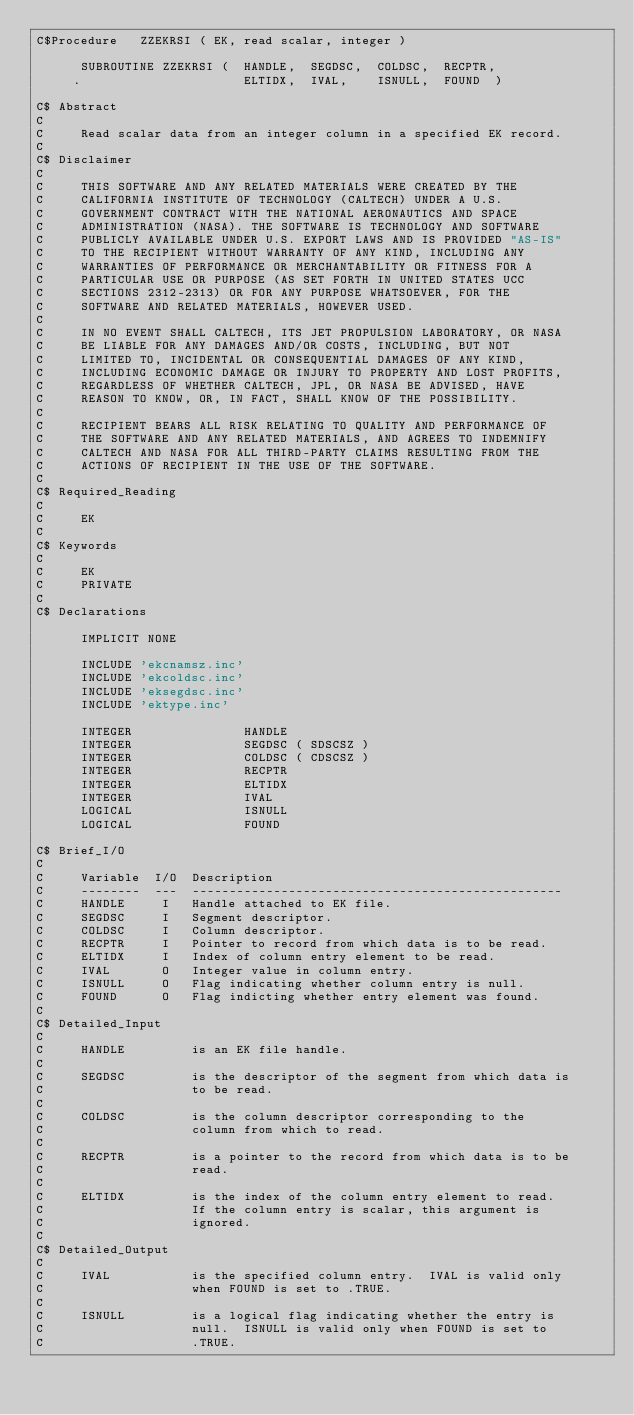<code> <loc_0><loc_0><loc_500><loc_500><_FORTRAN_>C$Procedure   ZZEKRSI ( EK, read scalar, integer )
 
      SUBROUTINE ZZEKRSI (  HANDLE,  SEGDSC,  COLDSC,  RECPTR,
     .                      ELTIDX,  IVAL,    ISNULL,  FOUND  )
 
C$ Abstract
C
C     Read scalar data from an integer column in a specified EK record.
C
C$ Disclaimer
C
C     THIS SOFTWARE AND ANY RELATED MATERIALS WERE CREATED BY THE
C     CALIFORNIA INSTITUTE OF TECHNOLOGY (CALTECH) UNDER A U.S.
C     GOVERNMENT CONTRACT WITH THE NATIONAL AERONAUTICS AND SPACE
C     ADMINISTRATION (NASA). THE SOFTWARE IS TECHNOLOGY AND SOFTWARE
C     PUBLICLY AVAILABLE UNDER U.S. EXPORT LAWS AND IS PROVIDED "AS-IS"
C     TO THE RECIPIENT WITHOUT WARRANTY OF ANY KIND, INCLUDING ANY
C     WARRANTIES OF PERFORMANCE OR MERCHANTABILITY OR FITNESS FOR A
C     PARTICULAR USE OR PURPOSE (AS SET FORTH IN UNITED STATES UCC
C     SECTIONS 2312-2313) OR FOR ANY PURPOSE WHATSOEVER, FOR THE
C     SOFTWARE AND RELATED MATERIALS, HOWEVER USED.
C
C     IN NO EVENT SHALL CALTECH, ITS JET PROPULSION LABORATORY, OR NASA
C     BE LIABLE FOR ANY DAMAGES AND/OR COSTS, INCLUDING, BUT NOT
C     LIMITED TO, INCIDENTAL OR CONSEQUENTIAL DAMAGES OF ANY KIND,
C     INCLUDING ECONOMIC DAMAGE OR INJURY TO PROPERTY AND LOST PROFITS,
C     REGARDLESS OF WHETHER CALTECH, JPL, OR NASA BE ADVISED, HAVE
C     REASON TO KNOW, OR, IN FACT, SHALL KNOW OF THE POSSIBILITY.
C
C     RECIPIENT BEARS ALL RISK RELATING TO QUALITY AND PERFORMANCE OF
C     THE SOFTWARE AND ANY RELATED MATERIALS, AND AGREES TO INDEMNIFY
C     CALTECH AND NASA FOR ALL THIRD-PARTY CLAIMS RESULTING FROM THE
C     ACTIONS OF RECIPIENT IN THE USE OF THE SOFTWARE.
C
C$ Required_Reading
C
C     EK
C
C$ Keywords
C
C     EK
C     PRIVATE
C
C$ Declarations
 
      IMPLICIT NONE

      INCLUDE 'ekcnamsz.inc'
      INCLUDE 'ekcoldsc.inc'
      INCLUDE 'eksegdsc.inc'
      INCLUDE 'ektype.inc'
 
      INTEGER               HANDLE
      INTEGER               SEGDSC ( SDSCSZ )
      INTEGER               COLDSC ( CDSCSZ )
      INTEGER               RECPTR
      INTEGER               ELTIDX
      INTEGER               IVAL
      LOGICAL               ISNULL
      LOGICAL               FOUND
 
C$ Brief_I/O
C
C     Variable  I/O  Description
C     --------  ---  --------------------------------------------------
C     HANDLE     I   Handle attached to EK file.
C     SEGDSC     I   Segment descriptor.
C     COLDSC     I   Column descriptor.
C     RECPTR     I   Pointer to record from which data is to be read.
C     ELTIDX     I   Index of column entry element to be read.
C     IVAL       O   Integer value in column entry.
C     ISNULL     O   Flag indicating whether column entry is null.
C     FOUND      O   Flag indicting whether entry element was found.
C
C$ Detailed_Input
C
C     HANDLE         is an EK file handle.
C
C     SEGDSC         is the descriptor of the segment from which data is
C                    to be read.
C
C     COLDSC         is the column descriptor corresponding to the
C                    column from which to read.
C
C     RECPTR         is a pointer to the record from which data is to be
C                    read.
C
C     ELTIDX         is the index of the column entry element to read.
C                    If the column entry is scalar, this argument is
C                    ignored.
C
C$ Detailed_Output
C
C     IVAL           is the specified column entry.  IVAL is valid only
C                    when FOUND is set to .TRUE.
C
C     ISNULL         is a logical flag indicating whether the entry is
C                    null.  ISNULL is valid only when FOUND is set to
C                    .TRUE.</code> 